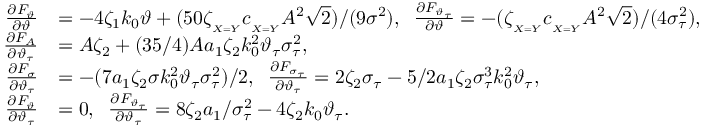<formula> <loc_0><loc_0><loc_500><loc_500>\begin{array} { r l } { \frac { \partial F _ { \vartheta } } { \partial \vartheta } } & { = - 4 \zeta _ { 1 } k _ { 0 } \vartheta + ( 5 0 \zeta _ { _ { X = Y } } c _ { _ { X = Y } } A ^ { 2 } \sqrt { 2 } ) / ( 9 \sigma ^ { 2 } ) , \, \frac { \partial F _ { \vartheta _ { \tau } } } { \partial \vartheta } = - ( \zeta _ { _ { X = Y } } c _ { _ { X = Y } } A ^ { 2 } \sqrt { 2 } ) / ( 4 \sigma _ { \tau } ^ { 2 } ) , } \\ { \frac { \partial F _ { A } } { \partial \vartheta _ { \tau } } } & { = A \zeta _ { 2 } + ( 3 5 / 4 ) A a _ { 1 } \zeta _ { 2 } k _ { 0 } ^ { 2 } \vartheta _ { \tau } \sigma _ { \tau } ^ { 2 } , } \\ { \frac { \partial F _ { \sigma } } { \partial \vartheta _ { \tau } } } & { = - ( 7 a _ { 1 } \zeta _ { 2 } \sigma k _ { 0 } ^ { 2 } \vartheta _ { \tau } \sigma _ { \tau } ^ { 2 } ) / 2 , \, \frac { \partial F _ { \sigma _ { \tau } } } { \partial \vartheta _ { \tau } } = 2 \zeta _ { 2 } \sigma _ { \tau } - 5 / 2 a _ { 1 } \zeta _ { 2 } \sigma _ { \tau } ^ { 3 } k _ { 0 } ^ { 2 } \vartheta _ { \tau } , } \\ { \frac { \partial F _ { \vartheta } } { \partial \vartheta _ { \tau } } } & { = 0 , \, \frac { \partial F _ { \vartheta _ { \tau } } } { \partial \vartheta _ { \tau } } = 8 \zeta _ { 2 } a _ { 1 } / \sigma _ { \tau } ^ { 2 } - 4 \zeta _ { 2 } k _ { 0 } \vartheta _ { \tau } . } \end{array}</formula> 